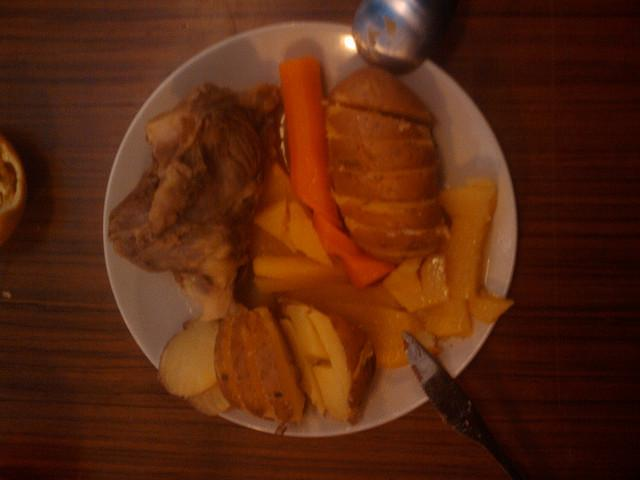What kind of vegetable is between the bread and the meat on top of the white plate? Please explain your reasoning. orange. It's a carrot, but for some reason the options only list colors. 